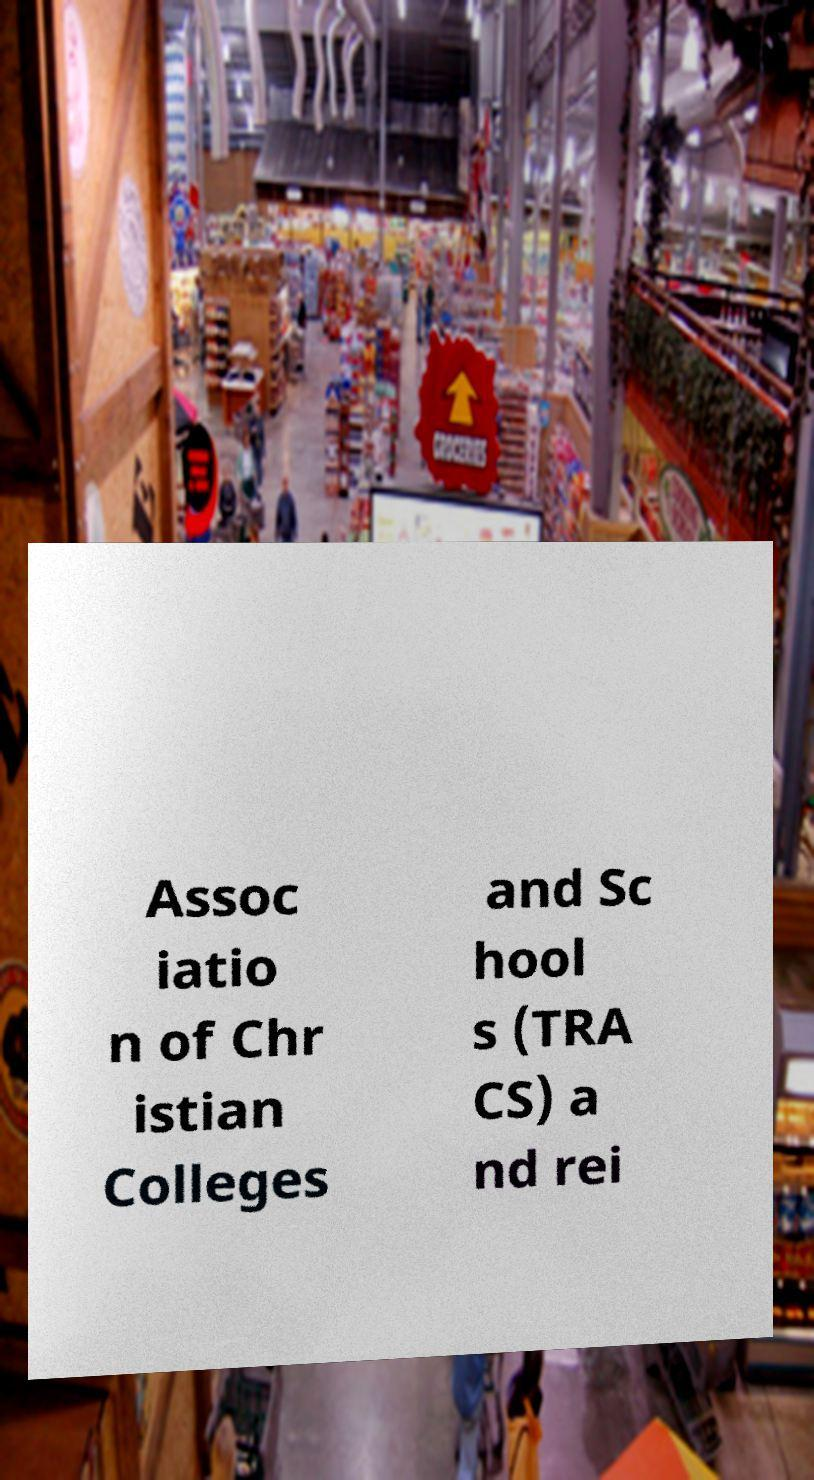I need the written content from this picture converted into text. Can you do that? Assoc iatio n of Chr istian Colleges and Sc hool s (TRA CS) a nd rei 